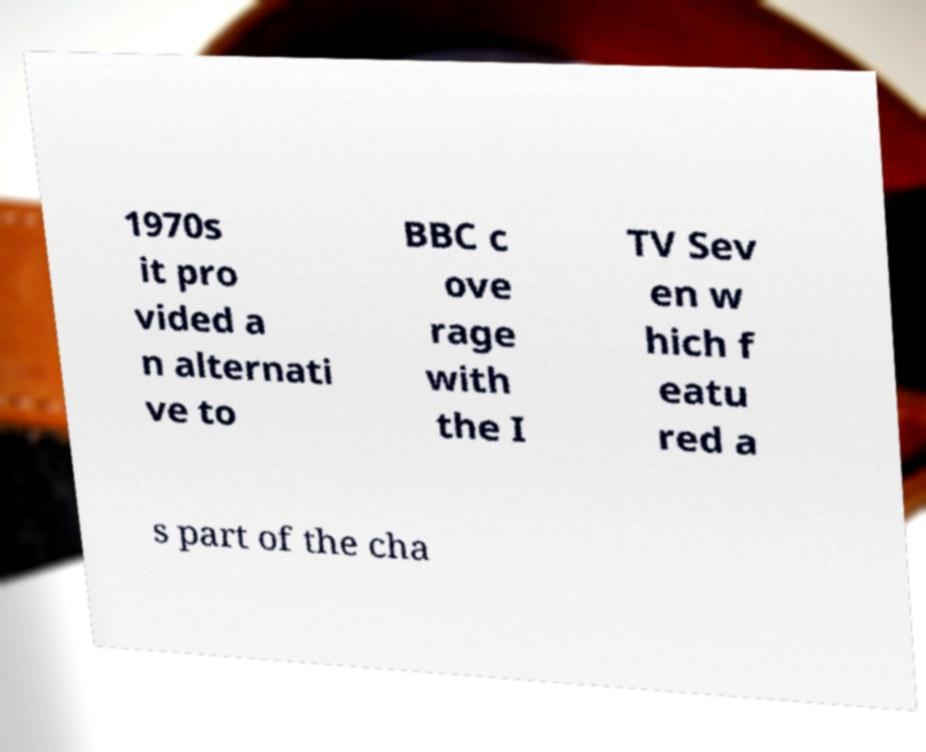Can you accurately transcribe the text from the provided image for me? 1970s it pro vided a n alternati ve to BBC c ove rage with the I TV Sev en w hich f eatu red a s part of the cha 